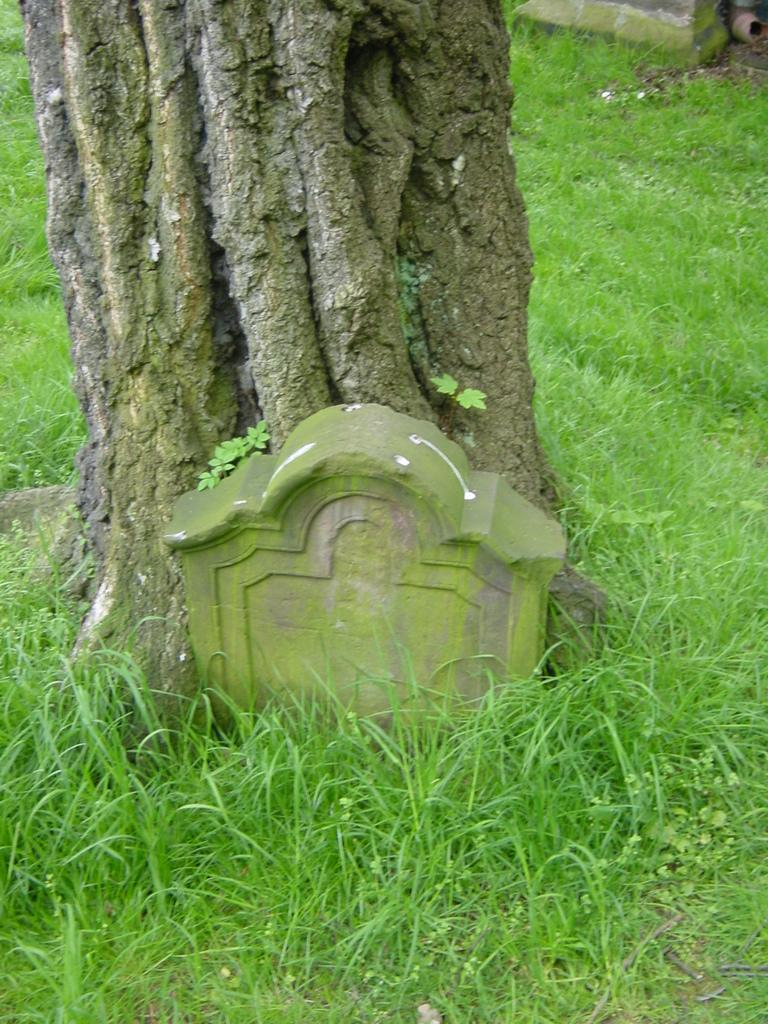What type of surface is visible in the image? There is a grass surface in the image. What can be seen on the grass surface? There is a tree branch in the image. What is located near the tree branch? There is a grave stone in the image. What is growing on the tree branch? There are plant saplings on the tree branch in the image. What color of paint is used on the tree branch in the image? There is no paint present on the tree branch in the image. The plant saplings are growing naturally on the branch. 